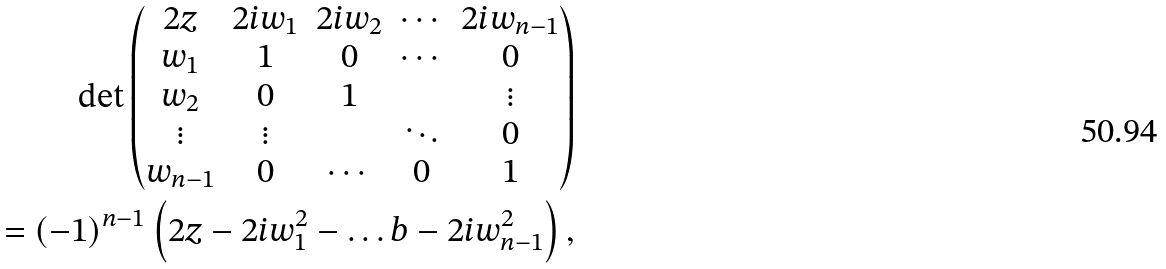Convert formula to latex. <formula><loc_0><loc_0><loc_500><loc_500>\det \begin{pmatrix} 2 z & 2 i w _ { 1 } & 2 i w _ { 2 } & \cdots & 2 i w _ { n - 1 } \\ w _ { 1 } & 1 & 0 & \cdots & 0 \\ w _ { 2 } & 0 & 1 & & \vdots \\ \vdots & \vdots & & \ddots & 0 \\ w _ { n - 1 } & 0 & \cdots & 0 & 1 \end{pmatrix} \\ = ( - 1 ) ^ { n - 1 } \left ( 2 z - 2 i w _ { 1 } ^ { 2 } - \dots b - 2 i w _ { n - 1 } ^ { 2 } \right ) ,</formula> 